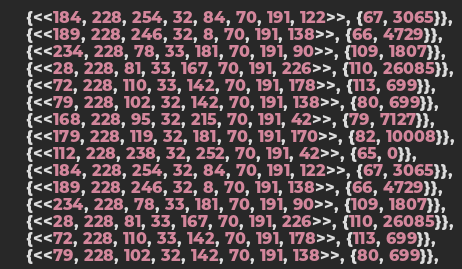<code> <loc_0><loc_0><loc_500><loc_500><_Elixir_>    {<<184, 228, 254, 32, 84, 70, 191, 122>>, {67, 3065}},
    {<<189, 228, 246, 32, 8, 70, 191, 138>>, {66, 4729}},
    {<<234, 228, 78, 33, 181, 70, 191, 90>>, {109, 1807}},
    {<<28, 228, 81, 33, 167, 70, 191, 226>>, {110, 26085}},
    {<<72, 228, 110, 33, 142, 70, 191, 178>>, {113, 699}},
    {<<79, 228, 102, 32, 142, 70, 191, 138>>, {80, 699}},
    {<<168, 228, 95, 32, 215, 70, 191, 42>>, {79, 7127}},
    {<<179, 228, 119, 32, 181, 70, 191, 170>>, {82, 10008}},
    {<<112, 228, 238, 32, 252, 70, 191, 42>>, {65, 0}},
    {<<184, 228, 254, 32, 84, 70, 191, 122>>, {67, 3065}},
    {<<189, 228, 246, 32, 8, 70, 191, 138>>, {66, 4729}},
    {<<234, 228, 78, 33, 181, 70, 191, 90>>, {109, 1807}},
    {<<28, 228, 81, 33, 167, 70, 191, 226>>, {110, 26085}},
    {<<72, 228, 110, 33, 142, 70, 191, 178>>, {113, 699}},
    {<<79, 228, 102, 32, 142, 70, 191, 138>>, {80, 699}},</code> 